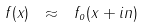<formula> <loc_0><loc_0><loc_500><loc_500>f ( x ) \ \approx \ f _ { o } ( x + i n )</formula> 